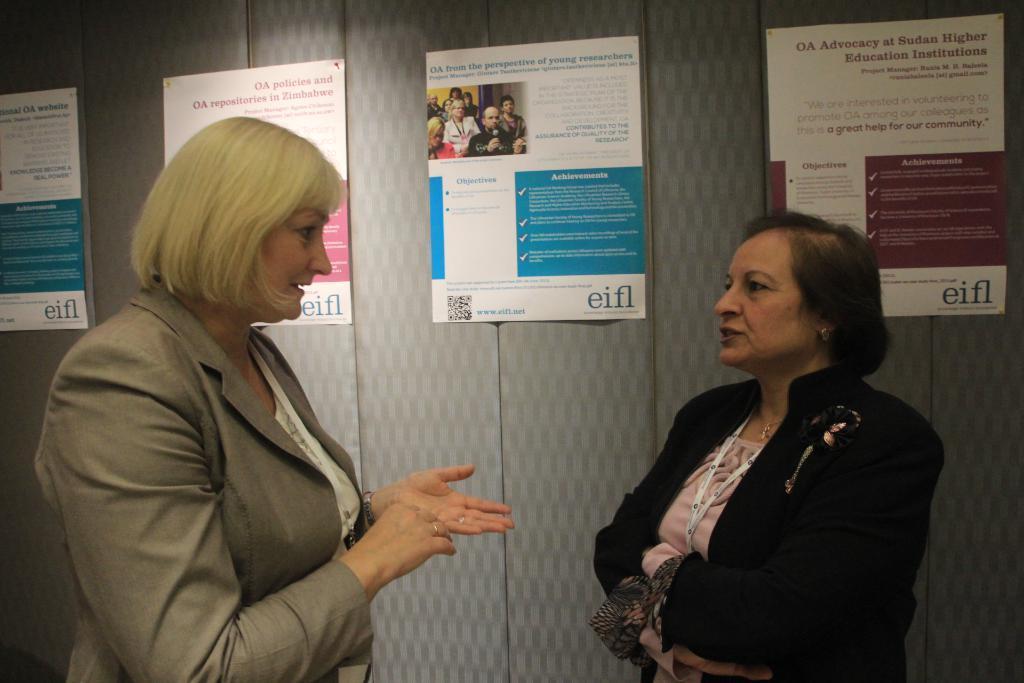Please provide a concise description of this image. 2 women are standing and talking to each other. They are wearing blazers. There are posters at the back. 